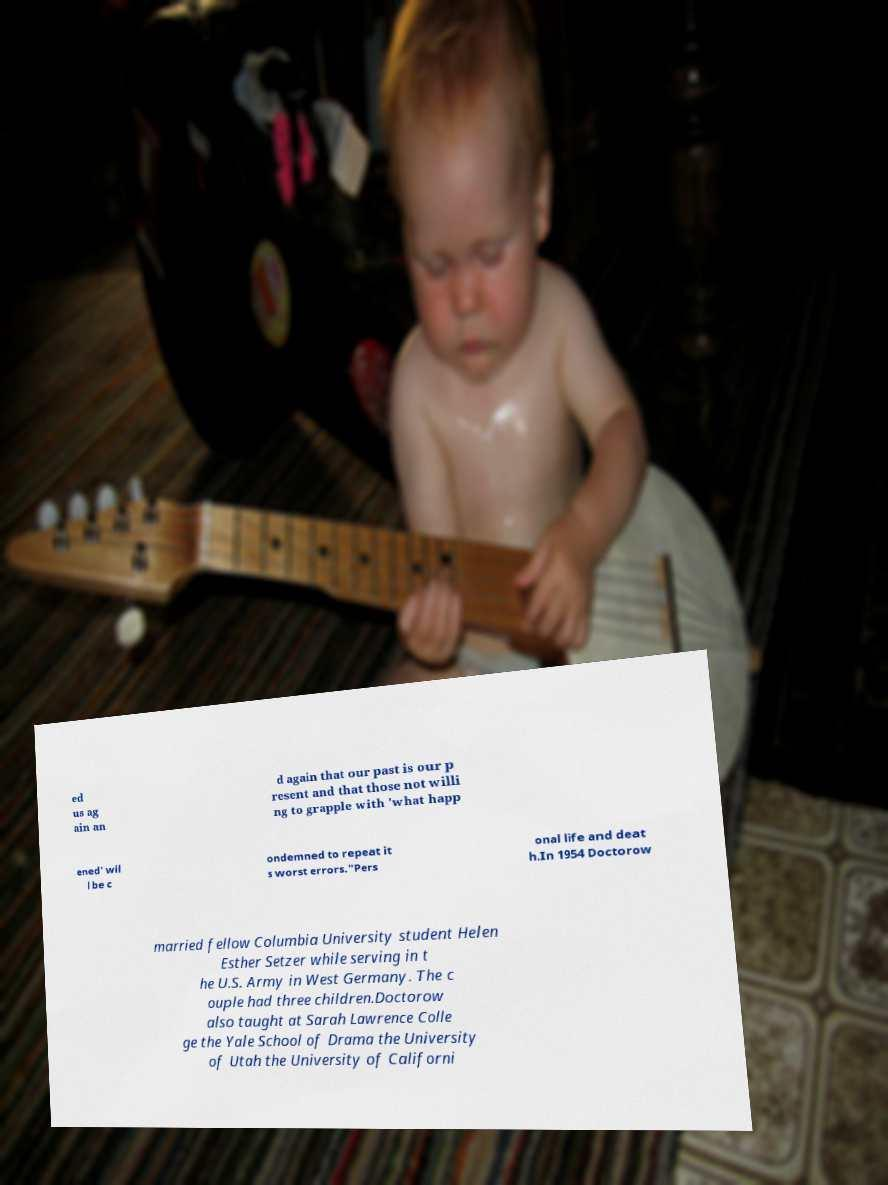Could you extract and type out the text from this image? ed us ag ain an d again that our past is our p resent and that those not willi ng to grapple with 'what happ ened' wil l be c ondemned to repeat it s worst errors."Pers onal life and deat h.In 1954 Doctorow married fellow Columbia University student Helen Esther Setzer while serving in t he U.S. Army in West Germany. The c ouple had three children.Doctorow also taught at Sarah Lawrence Colle ge the Yale School of Drama the University of Utah the University of Californi 